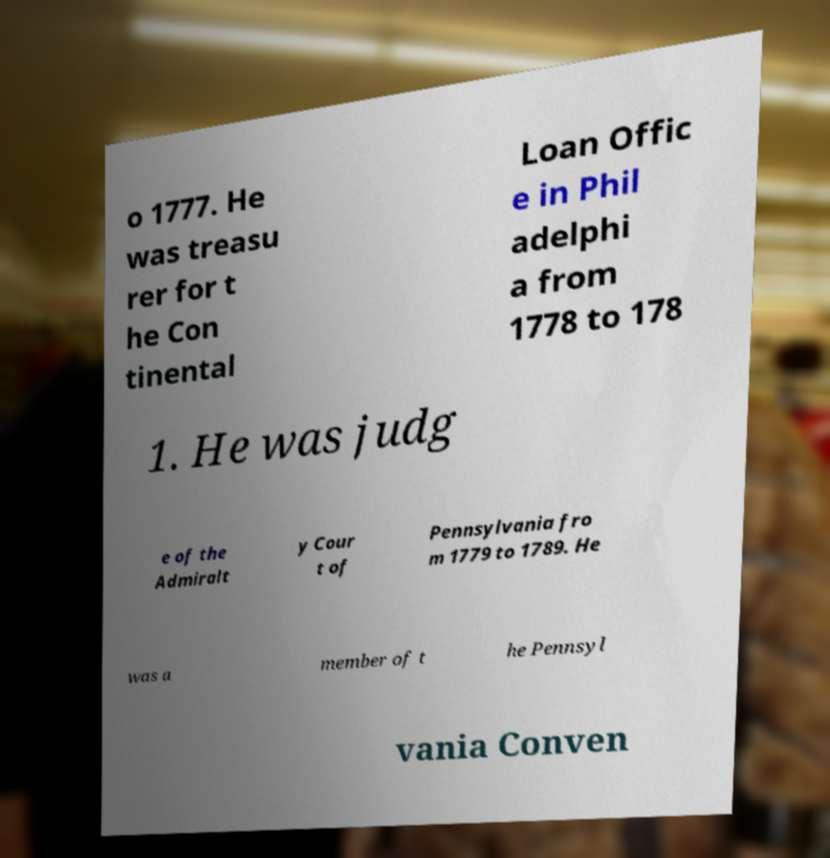For documentation purposes, I need the text within this image transcribed. Could you provide that? o 1777. He was treasu rer for t he Con tinental Loan Offic e in Phil adelphi a from 1778 to 178 1. He was judg e of the Admiralt y Cour t of Pennsylvania fro m 1779 to 1789. He was a member of t he Pennsyl vania Conven 